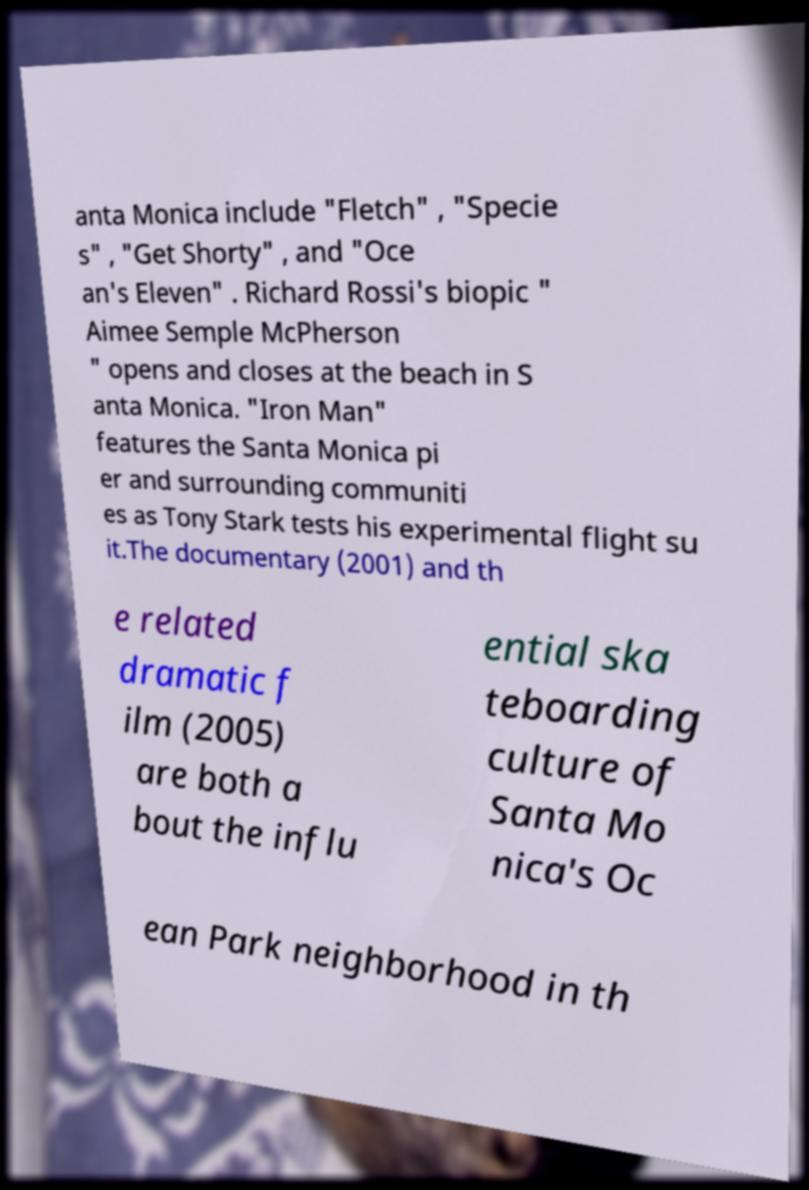Could you assist in decoding the text presented in this image and type it out clearly? anta Monica include "Fletch" , "Specie s" , "Get Shorty" , and "Oce an's Eleven" . Richard Rossi's biopic " Aimee Semple McPherson " opens and closes at the beach in S anta Monica. "Iron Man" features the Santa Monica pi er and surrounding communiti es as Tony Stark tests his experimental flight su it.The documentary (2001) and th e related dramatic f ilm (2005) are both a bout the influ ential ska teboarding culture of Santa Mo nica's Oc ean Park neighborhood in th 